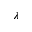<formula> <loc_0><loc_0><loc_500><loc_500>\lambda</formula> 